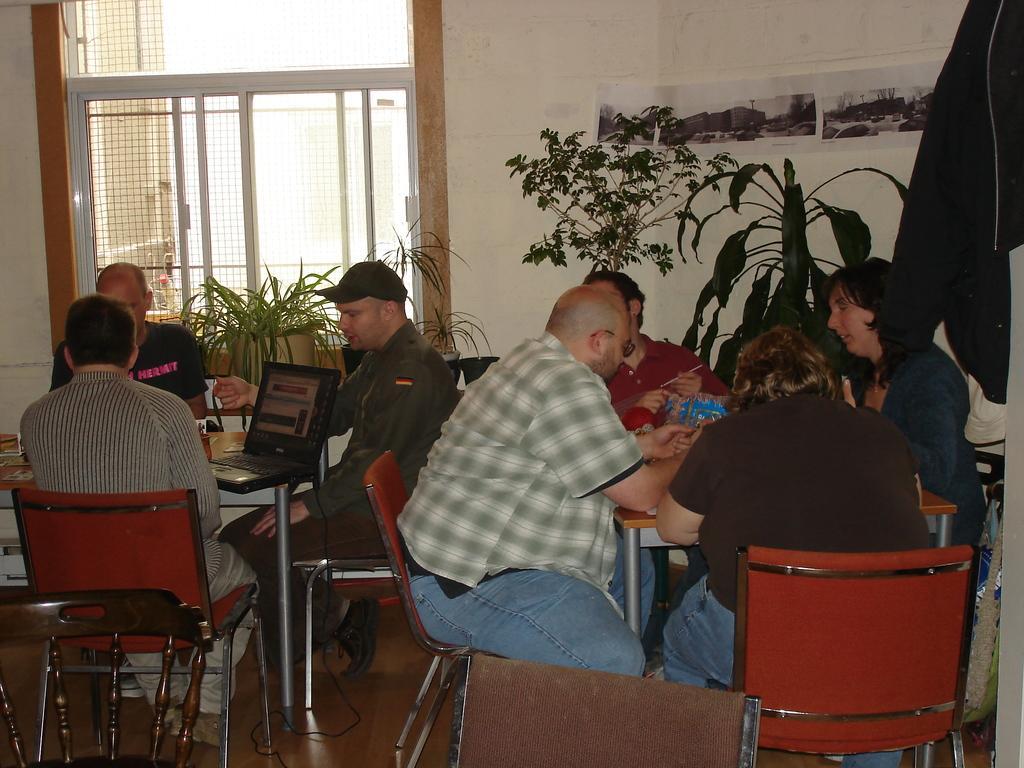Please provide a concise description of this image. In the image we can see there are people who are sitting on chair and on the table there is a laptop and behind the people there are plants. 